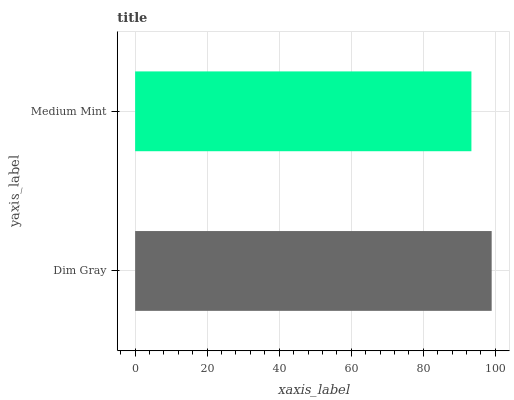Is Medium Mint the minimum?
Answer yes or no. Yes. Is Dim Gray the maximum?
Answer yes or no. Yes. Is Medium Mint the maximum?
Answer yes or no. No. Is Dim Gray greater than Medium Mint?
Answer yes or no. Yes. Is Medium Mint less than Dim Gray?
Answer yes or no. Yes. Is Medium Mint greater than Dim Gray?
Answer yes or no. No. Is Dim Gray less than Medium Mint?
Answer yes or no. No. Is Dim Gray the high median?
Answer yes or no. Yes. Is Medium Mint the low median?
Answer yes or no. Yes. Is Medium Mint the high median?
Answer yes or no. No. Is Dim Gray the low median?
Answer yes or no. No. 